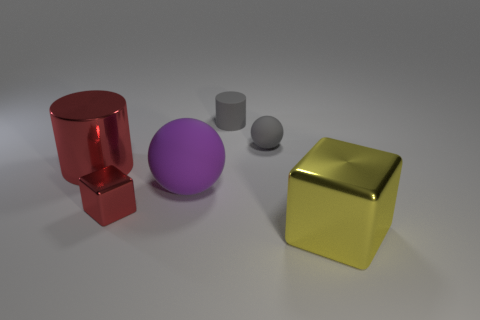What can you infer about the texture of the objects? The objects appear to have different textures. The red and gold objects have reflective metallic surfaces, suggesting a smooth and polished texture. The purple sphere and the smaller grey cylinder seem to have a matte finish, implying a rubbery texture that's less reflective and possibly softer to the touch. How about the lighting in the scene? Does it provide any particular ambiance or highlight certain features? The lighting in the scene casts soft shadows and gives a serene, almost studio-like quality to the image. It highlights the curves and edges of the objects, particularly accentuating the reflective properties of the metallic surfaces, which starkly contrast with the duller rubber textures. 